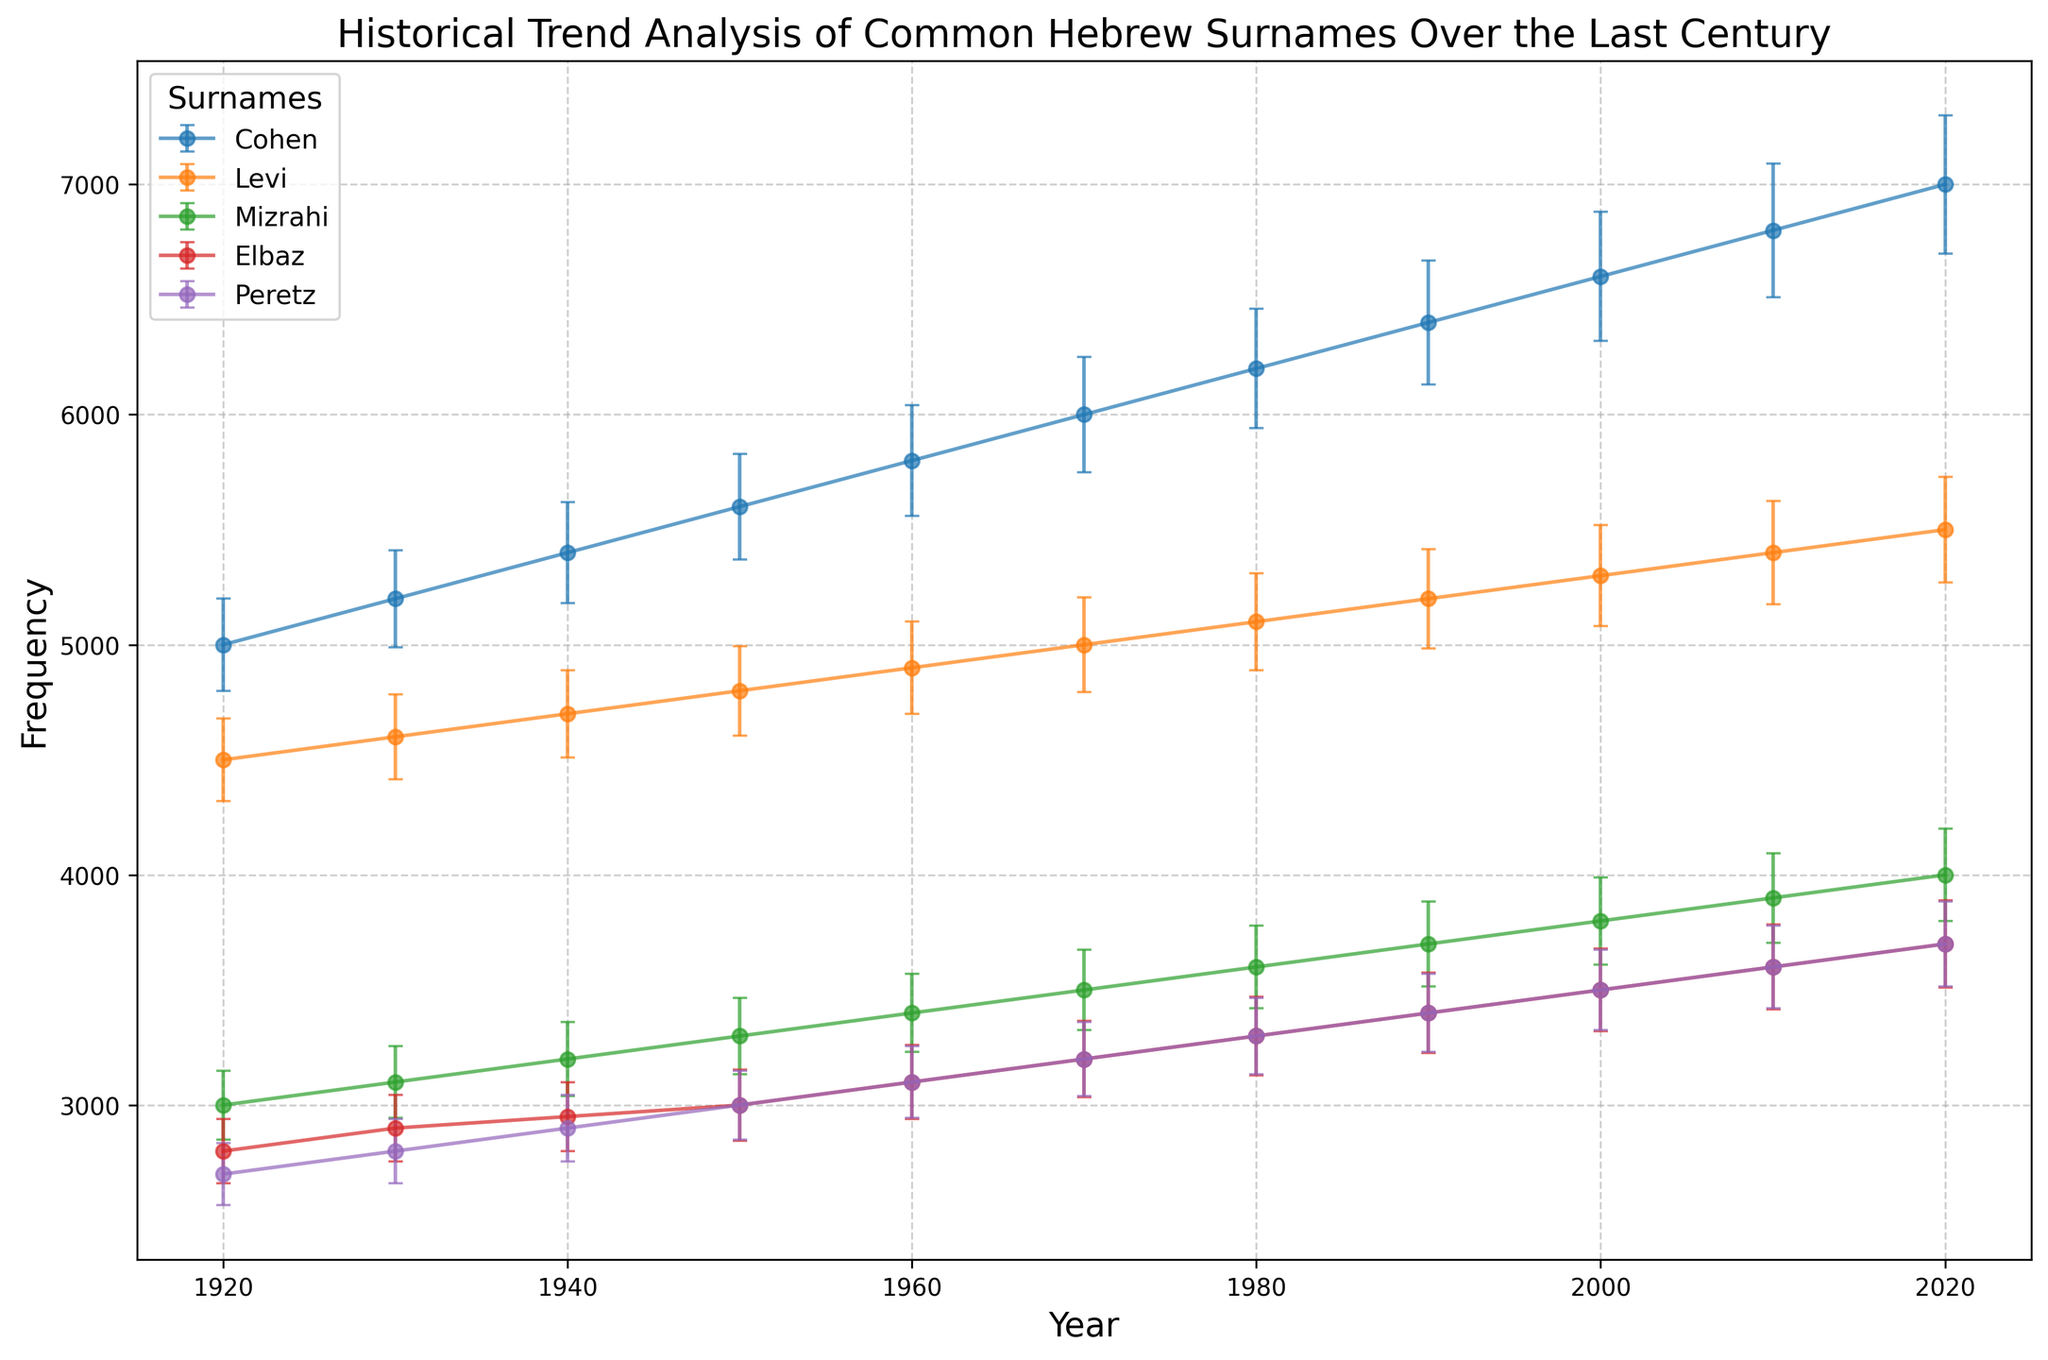What is the trend in the frequency of the surname "Cohen" from 1920 to 2020? The frequency of the surname "Cohen" increases steadily over the years from 1920 to 2020. Starting at 5000 in 1920, it rises to 7000 in 2020.
Answer: It increases steadily Which surname had the highest frequency in 1960? By examining the graph for the year 1960, the surname "Cohen" has the highest frequency, with approximately 5800 occurrences.
Answer: Cohen How does the frequency of "Levi" in 1930 compare to "Mizrahi" in the same year? In 1930, the frequency of the surname "Levi" is 4600, whereas the frequency of "Mizrahi" is 3100. Therefore, "Levi" is higher than "Mizrahi" by 1500 occurrences.
Answer: Levi is higher What is the combined frequency of the surnames "Elbaz" and "Peretz" in 1980? In 1980, "Elbaz" has a frequency of 3300, and "Peretz" has a frequency of 3300. Summing these values gives a combined frequency of 6600.
Answer: 6600 What is the average frequency of "Peretz" over the years 1920, 1930, and 1940? The frequencies are 2700 (1920), 2800 (1930), and 2900 (1940). Sum these values: 2700 + 2800 + 2900 = 8400. Divide by 3 to get the average: 8400 / 3 = 2800.
Answer: 2800 Which surname's frequency shows the most significant fluctuation over time considering error bars? Observing the trends and the length of error bars, "Peretz" shows significant fluctuations due to its relatively large error bars and the changes in frequency.
Answer: Peretz How does the frequency of "Elbaz" in 1920 compare to its frequency in 2020, considering the error bars? In 1920, "Elbaz" has a frequency of 2800 with an error of 140, meaning the actual range could be 2660 to 2940. In 2020, its frequency is 3700 with an error of 190, so the actual range could be 3510 to 3890. After considering the error margins, "Elbaz" frequency in 2020 is still higher than in 1920.
Answer: Higher in 2020 